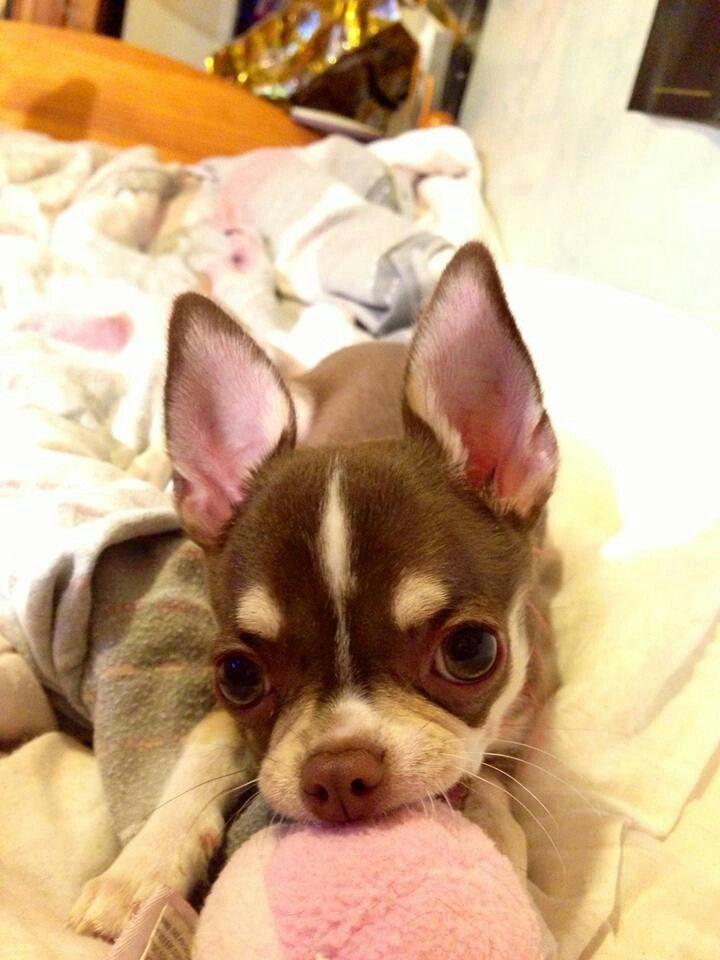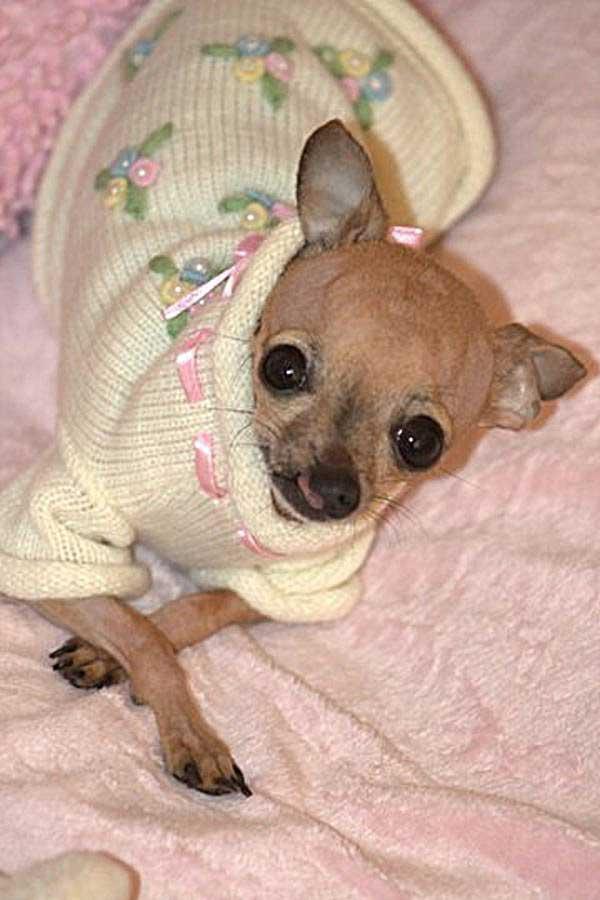The first image is the image on the left, the second image is the image on the right. Evaluate the accuracy of this statement regarding the images: "At least two dogs are snuggling together.". Is it true? Answer yes or no. No. The first image is the image on the left, the second image is the image on the right. Examine the images to the left and right. Is the description "All of the dogs are real and some are dressed like humans." accurate? Answer yes or no. Yes. 